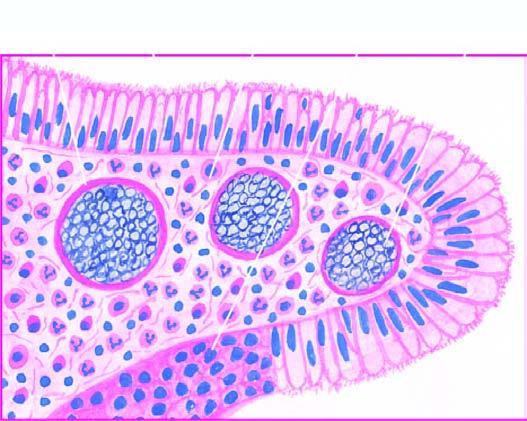what are present in sporangia as well as are intermingled in the inflammatory cell infiltrate?
Answer the question using a single word or phrase. Spores 